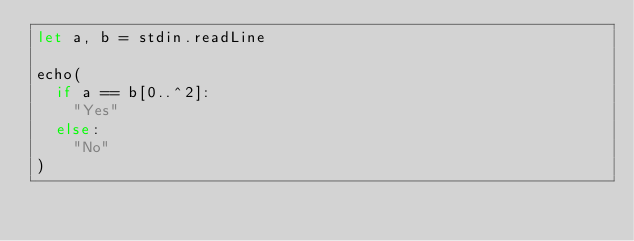Convert code to text. <code><loc_0><loc_0><loc_500><loc_500><_Nim_>let a, b = stdin.readLine

echo(
  if a == b[0..^2]:
    "Yes"
  else:
    "No"
)
</code> 